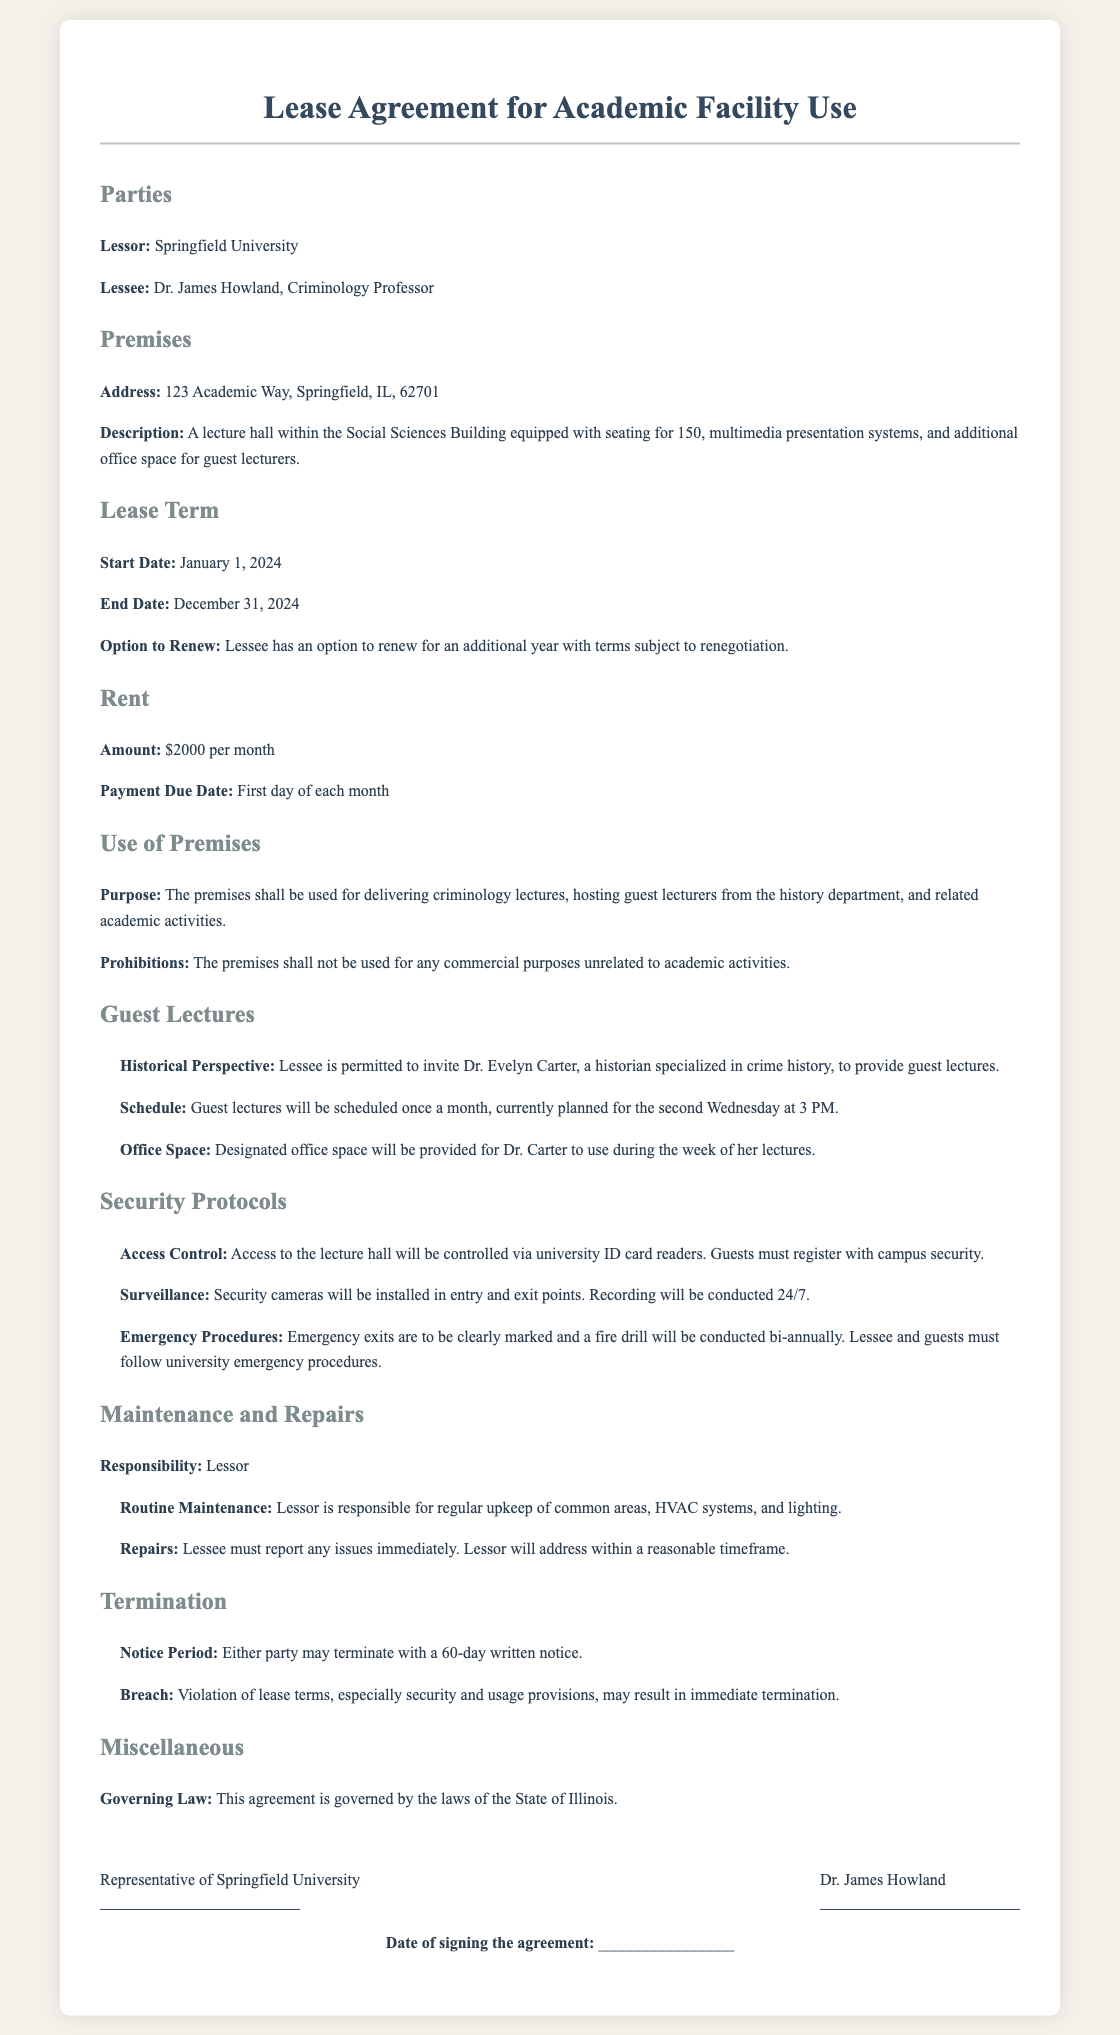What is the address of the premises? The address is explicitly mentioned in the document under the "Premises" section.
Answer: 123 Academic Way, Springfield, IL, 62701 What is the lease term start date? The start date can be found in the "Lease Term" section of the document.
Answer: January 1, 2024 Who is the Lessor? The Lessor's name is specified at the beginning of the document.
Answer: Springfield University How much is the rent per month? The rent amount is stated in the "Rent" section of the lease agreement.
Answer: $2000 per month How often are guest lectures scheduled? The frequency of the guest lectures is mentioned in the "Guest Lectures" section.
Answer: Once a month What is the notice period for termination? The notice period for termination is provided in the "Termination" section.
Answer: 60-day written notice Who is authorized to provide guest lectures? The person allowed to give guest lectures is listed in the "Guest Lectures" section.
Answer: Dr. Evelyn Carter What security measures are mentioned for access? The security protocols are detailed under "Security Protocols."
Answer: ID card readers What is the governing law for the agreement? The governing law is stated in the "Miscellaneous" section of the document.
Answer: State of Illinois 